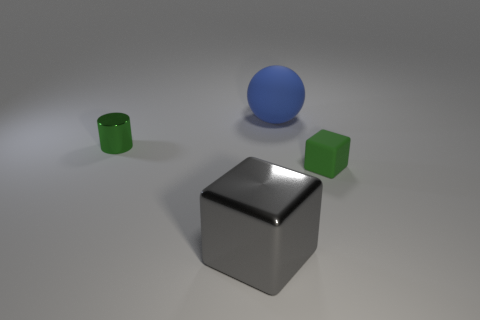Add 3 small purple objects. How many objects exist? 7 Subtract all cylinders. How many objects are left? 3 Add 4 small green blocks. How many small green blocks exist? 5 Subtract 0 brown cubes. How many objects are left? 4 Subtract all tiny cyan rubber blocks. Subtract all gray shiny objects. How many objects are left? 3 Add 2 blue rubber balls. How many blue rubber balls are left? 3 